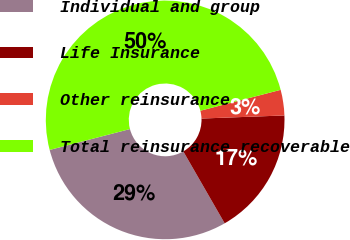<chart> <loc_0><loc_0><loc_500><loc_500><pie_chart><fcel>Individual and group<fcel>Life Insurance<fcel>Other reinsurance<fcel>Total reinsurance recoverable<nl><fcel>29.26%<fcel>17.28%<fcel>3.46%<fcel>50.0%<nl></chart> 